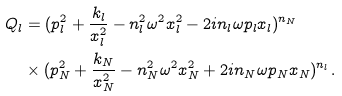<formula> <loc_0><loc_0><loc_500><loc_500>Q _ { l } & = ( p _ { l } ^ { 2 } + \frac { k _ { l } } { x _ { l } ^ { 2 } } - n _ { l } ^ { 2 } \omega ^ { 2 } x _ { l } ^ { 2 } - 2 i n _ { l } \omega p _ { l } x _ { l } ) ^ { n _ { N } } \\ & \times ( p _ { N } ^ { 2 } + \frac { k _ { N } } { x _ { N } ^ { 2 } } - n _ { N } ^ { 2 } \omega ^ { 2 } x _ { N } ^ { 2 } + 2 i n _ { N } \omega p _ { N } x _ { N } ) ^ { n _ { l } } .</formula> 